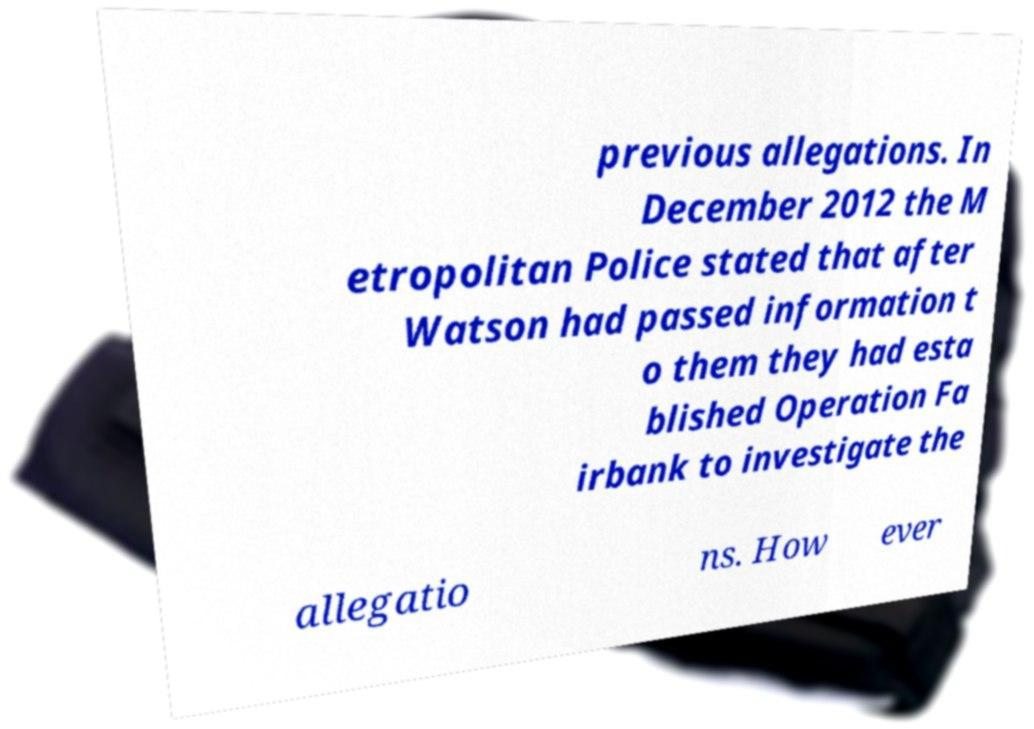Could you extract and type out the text from this image? previous allegations. In December 2012 the M etropolitan Police stated that after Watson had passed information t o them they had esta blished Operation Fa irbank to investigate the allegatio ns. How ever 